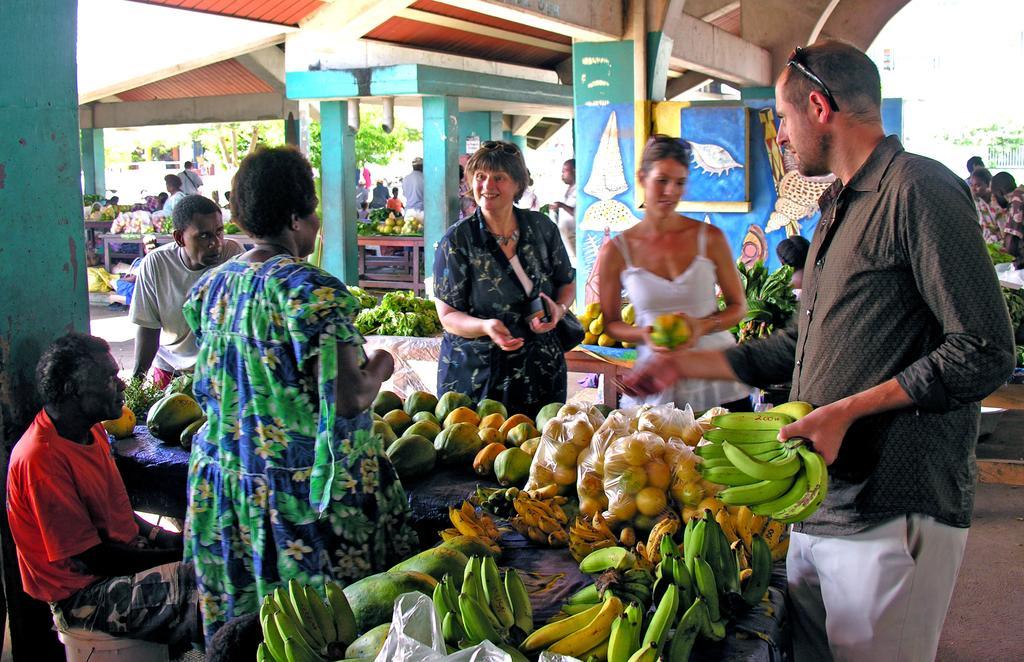How would you summarize this image in a sentence or two? This picture looks like a market and I can see few people are standing and a woman holding a papaya in her hands and a man holding bananas in one hand and a woman wore a bag and I can see a man seated and another woman standing and I can see few fruits vegetables and painting on the walls and trees on the back. 